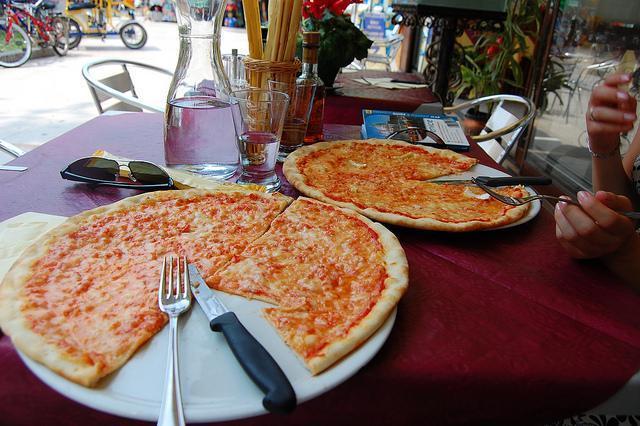How many hands are in the image?
Give a very brief answer. 2. How many cups are in the picture?
Give a very brief answer. 2. How many pizzas are in the picture?
Give a very brief answer. 3. How many chairs are there?
Give a very brief answer. 2. 